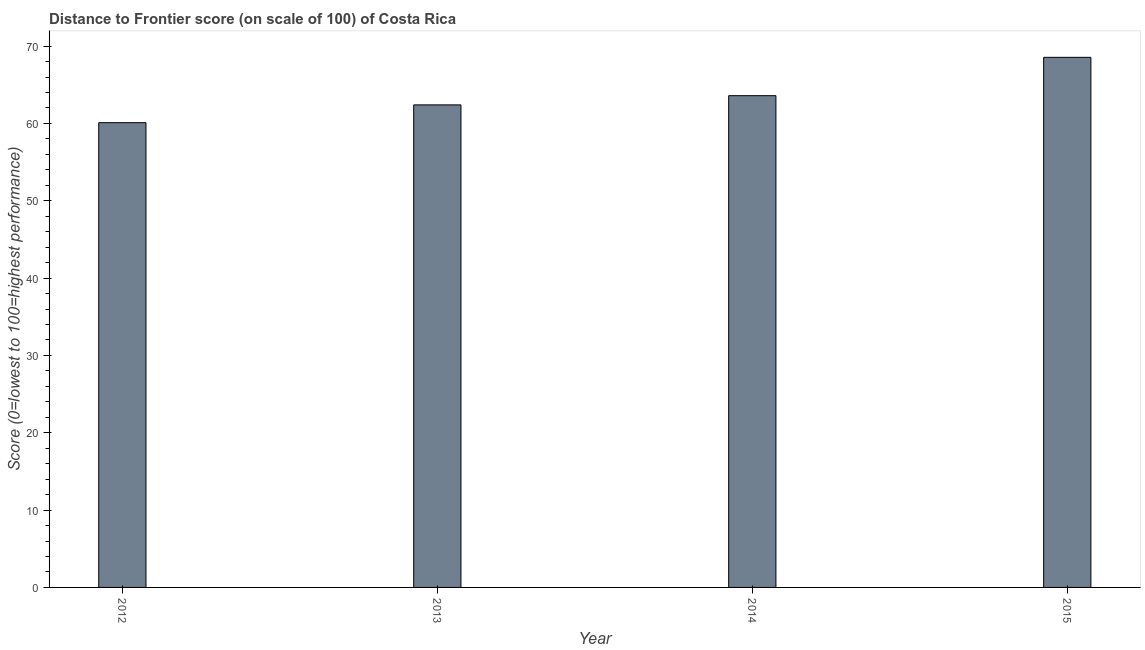Does the graph contain any zero values?
Keep it short and to the point. No. What is the title of the graph?
Your answer should be compact. Distance to Frontier score (on scale of 100) of Costa Rica. What is the label or title of the Y-axis?
Your answer should be compact. Score (0=lowest to 100=highest performance). What is the distance to frontier score in 2014?
Ensure brevity in your answer.  63.59. Across all years, what is the maximum distance to frontier score?
Give a very brief answer. 68.55. Across all years, what is the minimum distance to frontier score?
Provide a succinct answer. 60.1. In which year was the distance to frontier score maximum?
Your answer should be compact. 2015. In which year was the distance to frontier score minimum?
Your answer should be very brief. 2012. What is the sum of the distance to frontier score?
Make the answer very short. 254.64. What is the average distance to frontier score per year?
Offer a very short reply. 63.66. What is the median distance to frontier score?
Ensure brevity in your answer.  63. Is the distance to frontier score in 2012 less than that in 2015?
Keep it short and to the point. Yes. What is the difference between the highest and the second highest distance to frontier score?
Your answer should be very brief. 4.96. What is the difference between the highest and the lowest distance to frontier score?
Offer a terse response. 8.45. How many bars are there?
Provide a short and direct response. 4. How many years are there in the graph?
Your answer should be very brief. 4. Are the values on the major ticks of Y-axis written in scientific E-notation?
Ensure brevity in your answer.  No. What is the Score (0=lowest to 100=highest performance) in 2012?
Make the answer very short. 60.1. What is the Score (0=lowest to 100=highest performance) in 2013?
Your response must be concise. 62.4. What is the Score (0=lowest to 100=highest performance) in 2014?
Provide a succinct answer. 63.59. What is the Score (0=lowest to 100=highest performance) in 2015?
Provide a succinct answer. 68.55. What is the difference between the Score (0=lowest to 100=highest performance) in 2012 and 2013?
Provide a succinct answer. -2.3. What is the difference between the Score (0=lowest to 100=highest performance) in 2012 and 2014?
Ensure brevity in your answer.  -3.49. What is the difference between the Score (0=lowest to 100=highest performance) in 2012 and 2015?
Provide a succinct answer. -8.45. What is the difference between the Score (0=lowest to 100=highest performance) in 2013 and 2014?
Offer a terse response. -1.19. What is the difference between the Score (0=lowest to 100=highest performance) in 2013 and 2015?
Your response must be concise. -6.15. What is the difference between the Score (0=lowest to 100=highest performance) in 2014 and 2015?
Provide a short and direct response. -4.96. What is the ratio of the Score (0=lowest to 100=highest performance) in 2012 to that in 2014?
Give a very brief answer. 0.94. What is the ratio of the Score (0=lowest to 100=highest performance) in 2012 to that in 2015?
Offer a very short reply. 0.88. What is the ratio of the Score (0=lowest to 100=highest performance) in 2013 to that in 2014?
Provide a succinct answer. 0.98. What is the ratio of the Score (0=lowest to 100=highest performance) in 2013 to that in 2015?
Your answer should be very brief. 0.91. What is the ratio of the Score (0=lowest to 100=highest performance) in 2014 to that in 2015?
Your answer should be very brief. 0.93. 